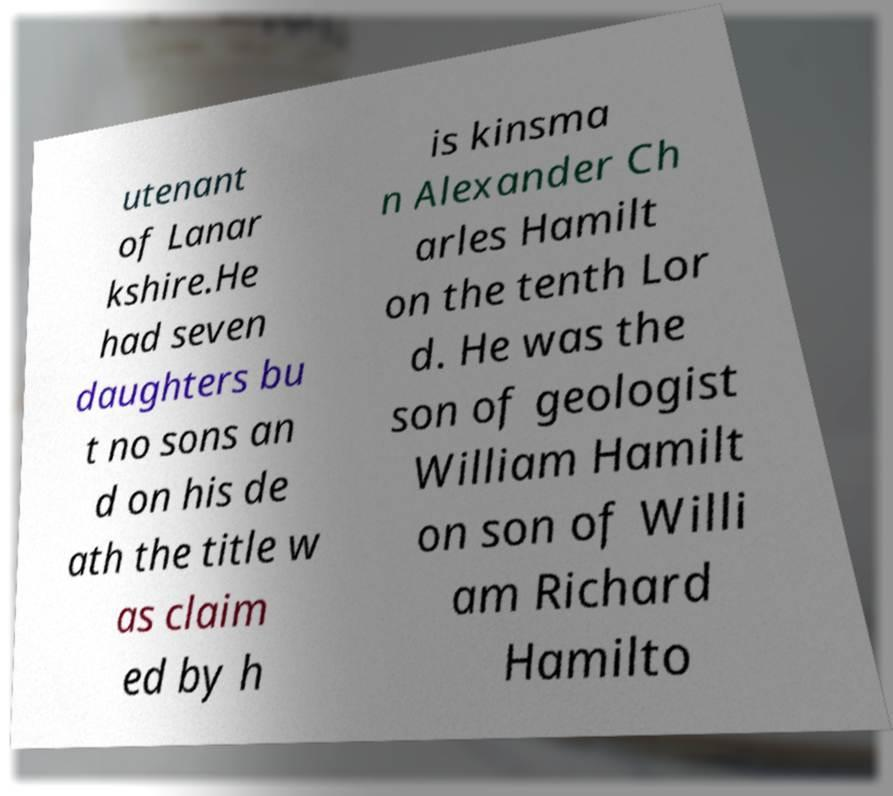Please identify and transcribe the text found in this image. utenant of Lanar kshire.He had seven daughters bu t no sons an d on his de ath the title w as claim ed by h is kinsma n Alexander Ch arles Hamilt on the tenth Lor d. He was the son of geologist William Hamilt on son of Willi am Richard Hamilto 